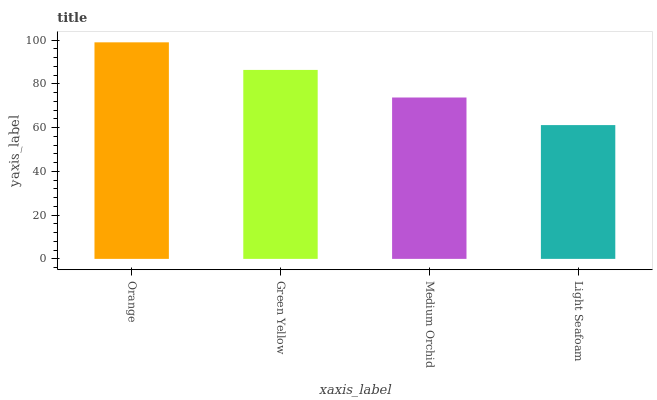Is Light Seafoam the minimum?
Answer yes or no. Yes. Is Orange the maximum?
Answer yes or no. Yes. Is Green Yellow the minimum?
Answer yes or no. No. Is Green Yellow the maximum?
Answer yes or no. No. Is Orange greater than Green Yellow?
Answer yes or no. Yes. Is Green Yellow less than Orange?
Answer yes or no. Yes. Is Green Yellow greater than Orange?
Answer yes or no. No. Is Orange less than Green Yellow?
Answer yes or no. No. Is Green Yellow the high median?
Answer yes or no. Yes. Is Medium Orchid the low median?
Answer yes or no. Yes. Is Medium Orchid the high median?
Answer yes or no. No. Is Green Yellow the low median?
Answer yes or no. No. 